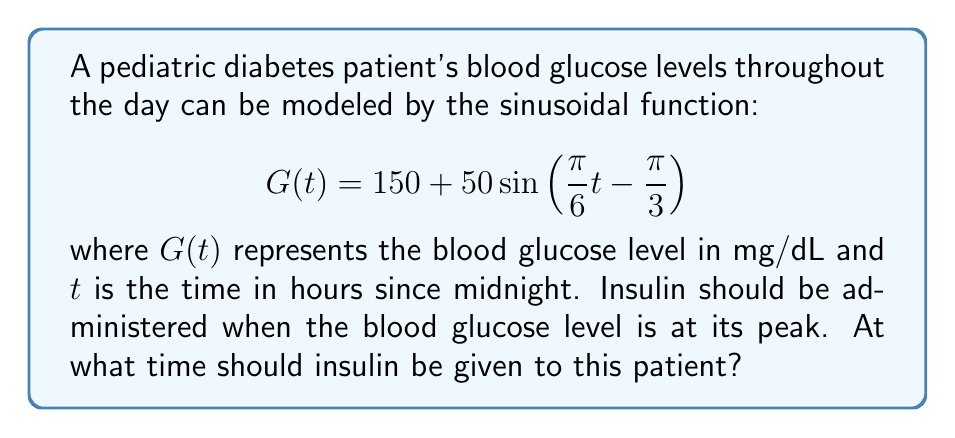Could you help me with this problem? To determine the optimal time for insulin administration, we need to find the maximum value of the function $G(t)$. For a sinusoidal function in the form $a\sin(bt + c) + d$, the maximum occurs when $bt + c = \frac{\pi}{2} + 2\pi n$, where $n$ is any integer.

1) Our function is in the form:
   $$ G(t) = 150 + 50\sin\left(\frac{\pi}{6}t - \frac{\pi}{3}\right) $$

2) Comparing this to the general form, we have:
   $b = \frac{\pi}{6}$ and $c = -\frac{\pi}{3}$

3) Set up the equation for the maximum:
   $$ \frac{\pi}{6}t - \frac{\pi}{3} = \frac{\pi}{2} + 2\pi n $$

4) Solve for $t$:
   $$ \frac{\pi}{6}t = \frac{\pi}{2} + \frac{\pi}{3} + 2\pi n $$
   $$ \frac{\pi}{6}t = \frac{5\pi}{6} + 2\pi n $$
   $$ t = 5 + 12n \text{ hours} $$

5) The first positive solution (n = 0) gives us 5 hours after midnight, or 5:00 AM.

6) To verify this is a maximum (not a minimum), we can check the second derivative or simply note that the amplitude is positive (50), so this indeed corresponds to a peak.
Answer: The optimal time for insulin administration is 5:00 AM. 